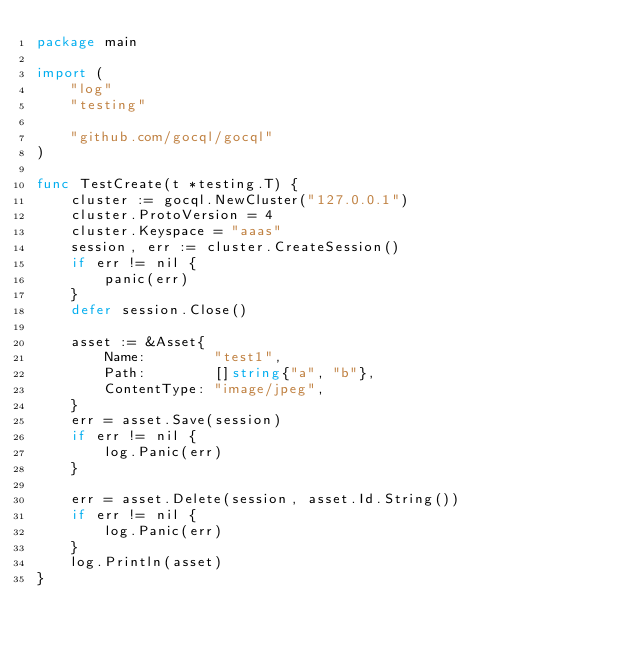Convert code to text. <code><loc_0><loc_0><loc_500><loc_500><_Go_>package main

import (
	"log"
	"testing"

	"github.com/gocql/gocql"
)

func TestCreate(t *testing.T) {
	cluster := gocql.NewCluster("127.0.0.1")
	cluster.ProtoVersion = 4
	cluster.Keyspace = "aaas"
	session, err := cluster.CreateSession()
	if err != nil {
		panic(err)
	}
	defer session.Close()

	asset := &Asset{
		Name:        "test1",
		Path:        []string{"a", "b"},
		ContentType: "image/jpeg",
	}
	err = asset.Save(session)
	if err != nil {
		log.Panic(err)
	}

	err = asset.Delete(session, asset.Id.String())
	if err != nil {
		log.Panic(err)
	}
	log.Println(asset)
}
</code> 